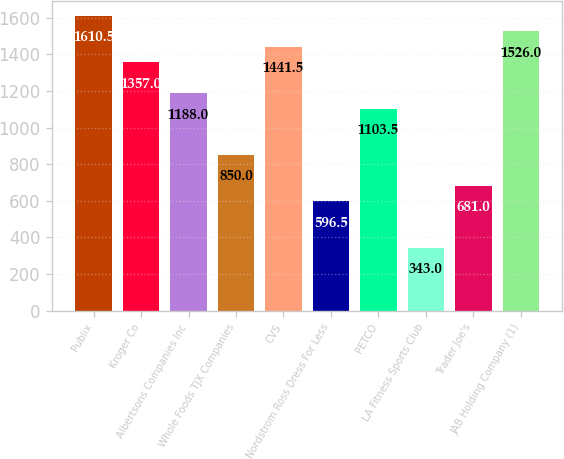Convert chart. <chart><loc_0><loc_0><loc_500><loc_500><bar_chart><fcel>Publix<fcel>Kroger Co<fcel>Albertsons Companies Inc<fcel>Whole Foods TJX Companies<fcel>CVS<fcel>Nordstrom Ross Dress For Less<fcel>PETCO<fcel>LA Fitness Sports Club<fcel>Trader Joe's<fcel>JAB Holding Company (1)<nl><fcel>1610.5<fcel>1357<fcel>1188<fcel>850<fcel>1441.5<fcel>596.5<fcel>1103.5<fcel>343<fcel>681<fcel>1526<nl></chart> 